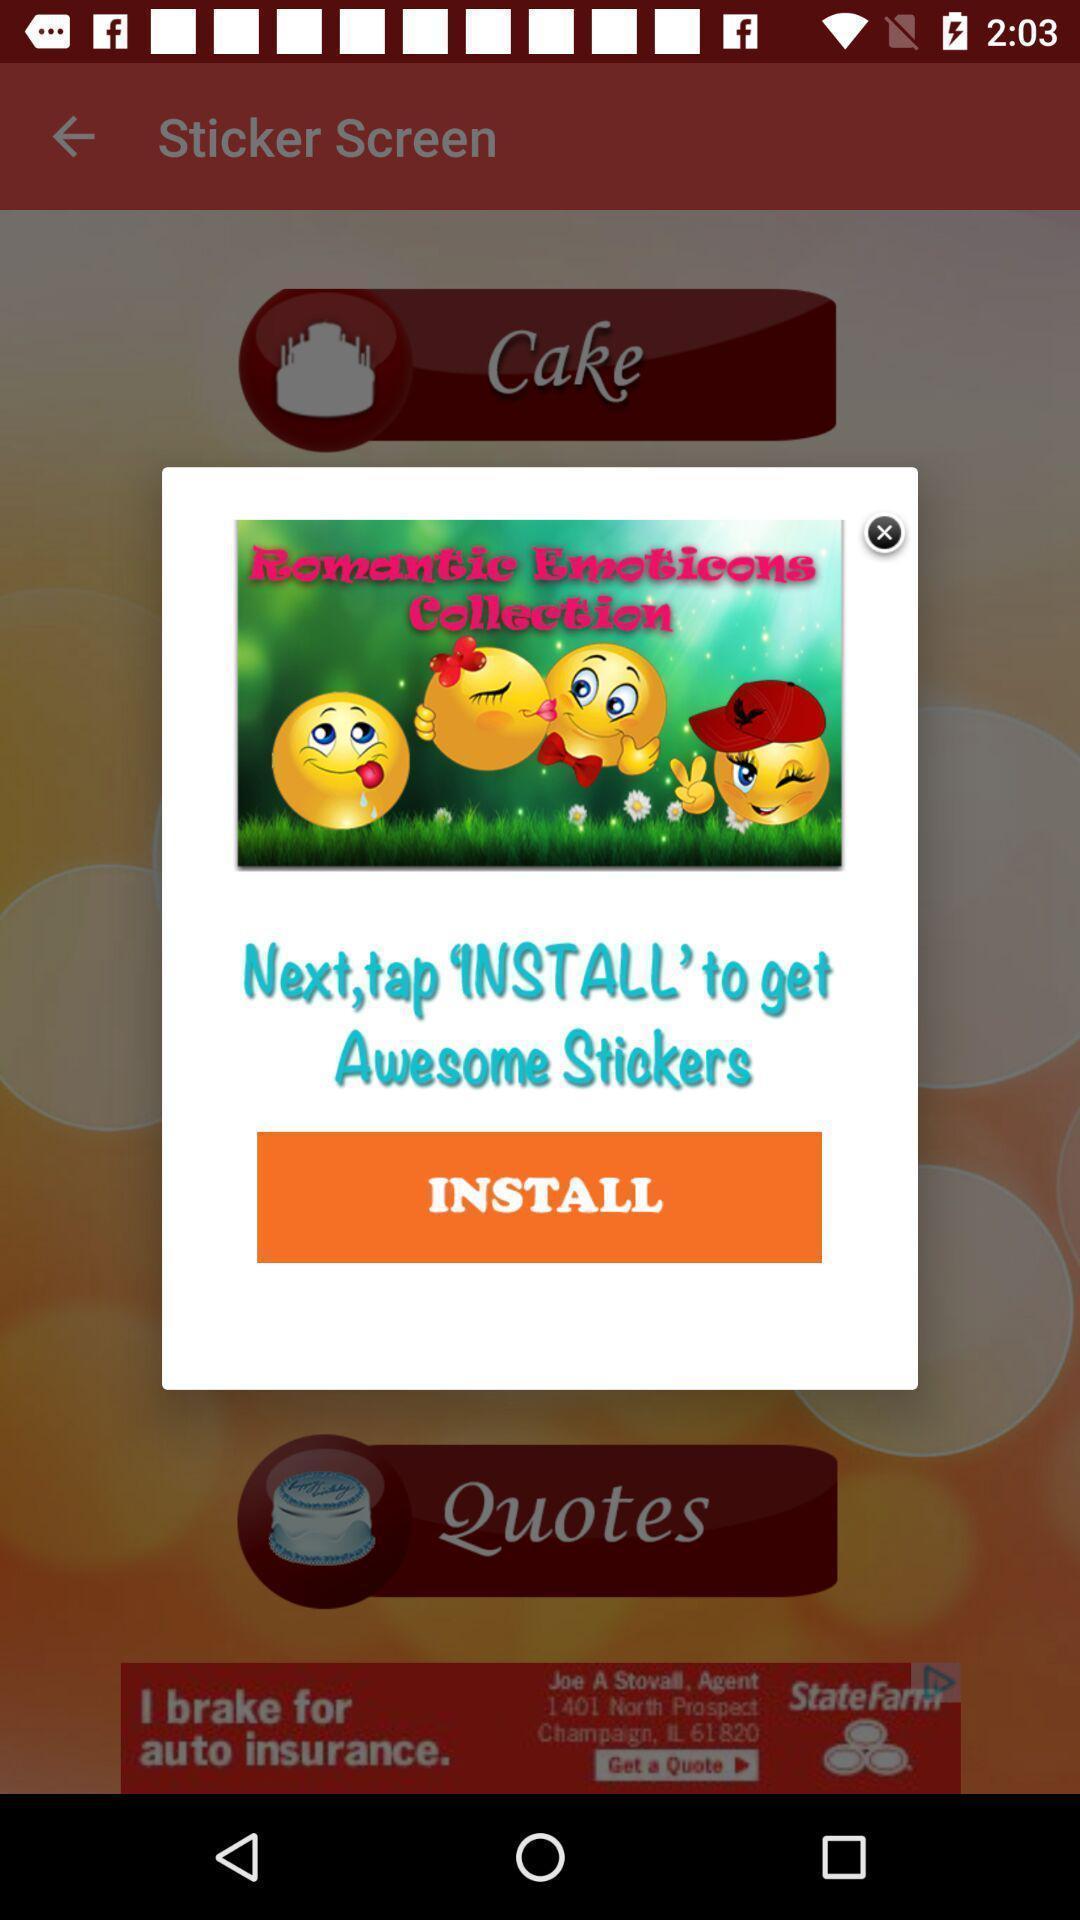Provide a textual representation of this image. Pop-up with options in a greeting cards app. 